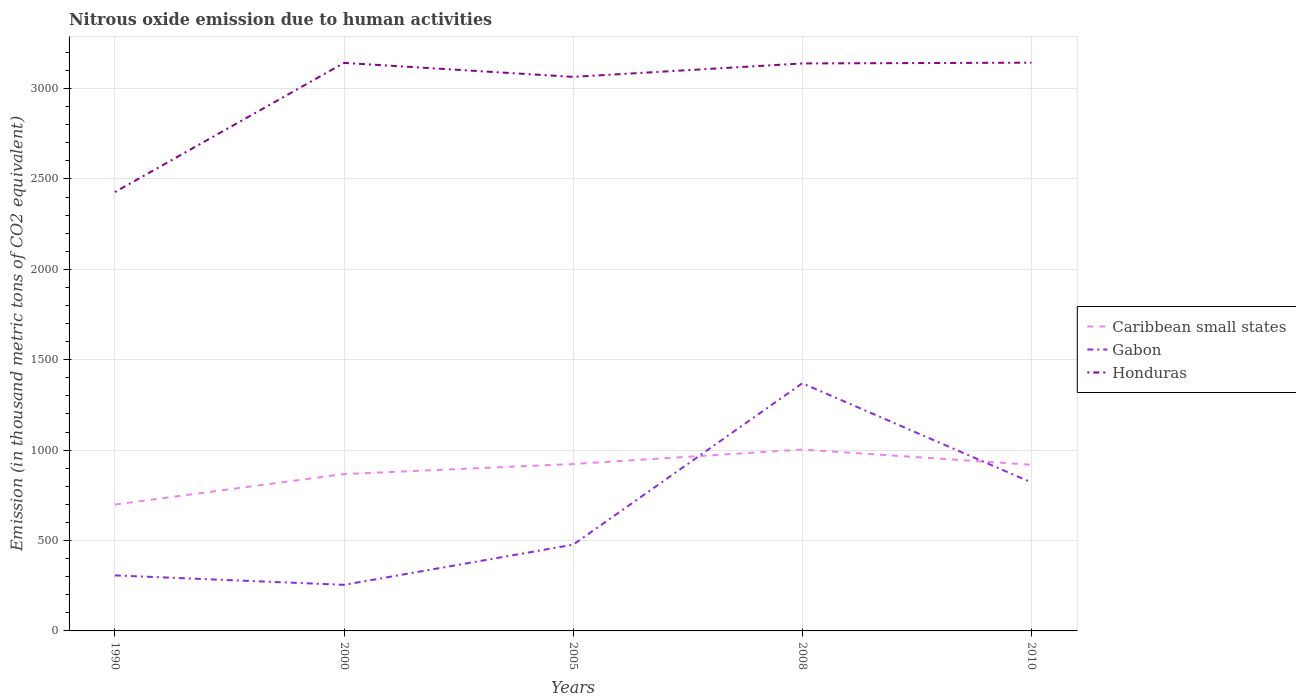Does the line corresponding to Honduras intersect with the line corresponding to Gabon?
Make the answer very short. No. Across all years, what is the maximum amount of nitrous oxide emitted in Caribbean small states?
Ensure brevity in your answer.  699.1. What is the total amount of nitrous oxide emitted in Caribbean small states in the graph?
Your response must be concise. -304.3. What is the difference between the highest and the second highest amount of nitrous oxide emitted in Gabon?
Give a very brief answer. 1115.1. How many lines are there?
Offer a terse response. 3. What is the difference between two consecutive major ticks on the Y-axis?
Your answer should be compact. 500. Does the graph contain any zero values?
Give a very brief answer. No. Does the graph contain grids?
Your response must be concise. Yes. Where does the legend appear in the graph?
Give a very brief answer. Center right. What is the title of the graph?
Your answer should be very brief. Nitrous oxide emission due to human activities. What is the label or title of the X-axis?
Offer a terse response. Years. What is the label or title of the Y-axis?
Provide a succinct answer. Emission (in thousand metric tons of CO2 equivalent). What is the Emission (in thousand metric tons of CO2 equivalent) in Caribbean small states in 1990?
Make the answer very short. 699.1. What is the Emission (in thousand metric tons of CO2 equivalent) of Gabon in 1990?
Offer a terse response. 307.1. What is the Emission (in thousand metric tons of CO2 equivalent) in Honduras in 1990?
Give a very brief answer. 2427.6. What is the Emission (in thousand metric tons of CO2 equivalent) of Caribbean small states in 2000?
Keep it short and to the point. 867.7. What is the Emission (in thousand metric tons of CO2 equivalent) of Gabon in 2000?
Provide a succinct answer. 254.9. What is the Emission (in thousand metric tons of CO2 equivalent) in Honduras in 2000?
Your response must be concise. 3142.2. What is the Emission (in thousand metric tons of CO2 equivalent) in Caribbean small states in 2005?
Your answer should be very brief. 923.3. What is the Emission (in thousand metric tons of CO2 equivalent) in Gabon in 2005?
Your answer should be very brief. 477.1. What is the Emission (in thousand metric tons of CO2 equivalent) in Honduras in 2005?
Make the answer very short. 3064.9. What is the Emission (in thousand metric tons of CO2 equivalent) of Caribbean small states in 2008?
Give a very brief answer. 1003.4. What is the Emission (in thousand metric tons of CO2 equivalent) in Gabon in 2008?
Your answer should be compact. 1370. What is the Emission (in thousand metric tons of CO2 equivalent) of Honduras in 2008?
Make the answer very short. 3139.2. What is the Emission (in thousand metric tons of CO2 equivalent) in Caribbean small states in 2010?
Offer a very short reply. 919.1. What is the Emission (in thousand metric tons of CO2 equivalent) in Gabon in 2010?
Your answer should be very brief. 821.3. What is the Emission (in thousand metric tons of CO2 equivalent) of Honduras in 2010?
Your answer should be very brief. 3143.4. Across all years, what is the maximum Emission (in thousand metric tons of CO2 equivalent) of Caribbean small states?
Give a very brief answer. 1003.4. Across all years, what is the maximum Emission (in thousand metric tons of CO2 equivalent) of Gabon?
Your answer should be compact. 1370. Across all years, what is the maximum Emission (in thousand metric tons of CO2 equivalent) in Honduras?
Ensure brevity in your answer.  3143.4. Across all years, what is the minimum Emission (in thousand metric tons of CO2 equivalent) of Caribbean small states?
Your response must be concise. 699.1. Across all years, what is the minimum Emission (in thousand metric tons of CO2 equivalent) in Gabon?
Your answer should be very brief. 254.9. Across all years, what is the minimum Emission (in thousand metric tons of CO2 equivalent) of Honduras?
Provide a succinct answer. 2427.6. What is the total Emission (in thousand metric tons of CO2 equivalent) in Caribbean small states in the graph?
Your response must be concise. 4412.6. What is the total Emission (in thousand metric tons of CO2 equivalent) of Gabon in the graph?
Ensure brevity in your answer.  3230.4. What is the total Emission (in thousand metric tons of CO2 equivalent) of Honduras in the graph?
Your response must be concise. 1.49e+04. What is the difference between the Emission (in thousand metric tons of CO2 equivalent) in Caribbean small states in 1990 and that in 2000?
Make the answer very short. -168.6. What is the difference between the Emission (in thousand metric tons of CO2 equivalent) in Gabon in 1990 and that in 2000?
Your answer should be compact. 52.2. What is the difference between the Emission (in thousand metric tons of CO2 equivalent) in Honduras in 1990 and that in 2000?
Keep it short and to the point. -714.6. What is the difference between the Emission (in thousand metric tons of CO2 equivalent) in Caribbean small states in 1990 and that in 2005?
Your answer should be very brief. -224.2. What is the difference between the Emission (in thousand metric tons of CO2 equivalent) of Gabon in 1990 and that in 2005?
Give a very brief answer. -170. What is the difference between the Emission (in thousand metric tons of CO2 equivalent) of Honduras in 1990 and that in 2005?
Keep it short and to the point. -637.3. What is the difference between the Emission (in thousand metric tons of CO2 equivalent) in Caribbean small states in 1990 and that in 2008?
Your answer should be compact. -304.3. What is the difference between the Emission (in thousand metric tons of CO2 equivalent) in Gabon in 1990 and that in 2008?
Give a very brief answer. -1062.9. What is the difference between the Emission (in thousand metric tons of CO2 equivalent) in Honduras in 1990 and that in 2008?
Provide a short and direct response. -711.6. What is the difference between the Emission (in thousand metric tons of CO2 equivalent) of Caribbean small states in 1990 and that in 2010?
Your answer should be compact. -220. What is the difference between the Emission (in thousand metric tons of CO2 equivalent) of Gabon in 1990 and that in 2010?
Provide a short and direct response. -514.2. What is the difference between the Emission (in thousand metric tons of CO2 equivalent) in Honduras in 1990 and that in 2010?
Your answer should be compact. -715.8. What is the difference between the Emission (in thousand metric tons of CO2 equivalent) in Caribbean small states in 2000 and that in 2005?
Your answer should be compact. -55.6. What is the difference between the Emission (in thousand metric tons of CO2 equivalent) in Gabon in 2000 and that in 2005?
Ensure brevity in your answer.  -222.2. What is the difference between the Emission (in thousand metric tons of CO2 equivalent) of Honduras in 2000 and that in 2005?
Your answer should be very brief. 77.3. What is the difference between the Emission (in thousand metric tons of CO2 equivalent) in Caribbean small states in 2000 and that in 2008?
Your answer should be compact. -135.7. What is the difference between the Emission (in thousand metric tons of CO2 equivalent) of Gabon in 2000 and that in 2008?
Give a very brief answer. -1115.1. What is the difference between the Emission (in thousand metric tons of CO2 equivalent) of Caribbean small states in 2000 and that in 2010?
Keep it short and to the point. -51.4. What is the difference between the Emission (in thousand metric tons of CO2 equivalent) in Gabon in 2000 and that in 2010?
Provide a short and direct response. -566.4. What is the difference between the Emission (in thousand metric tons of CO2 equivalent) of Honduras in 2000 and that in 2010?
Keep it short and to the point. -1.2. What is the difference between the Emission (in thousand metric tons of CO2 equivalent) in Caribbean small states in 2005 and that in 2008?
Offer a very short reply. -80.1. What is the difference between the Emission (in thousand metric tons of CO2 equivalent) in Gabon in 2005 and that in 2008?
Make the answer very short. -892.9. What is the difference between the Emission (in thousand metric tons of CO2 equivalent) of Honduras in 2005 and that in 2008?
Provide a succinct answer. -74.3. What is the difference between the Emission (in thousand metric tons of CO2 equivalent) in Caribbean small states in 2005 and that in 2010?
Keep it short and to the point. 4.2. What is the difference between the Emission (in thousand metric tons of CO2 equivalent) of Gabon in 2005 and that in 2010?
Ensure brevity in your answer.  -344.2. What is the difference between the Emission (in thousand metric tons of CO2 equivalent) in Honduras in 2005 and that in 2010?
Provide a short and direct response. -78.5. What is the difference between the Emission (in thousand metric tons of CO2 equivalent) of Caribbean small states in 2008 and that in 2010?
Your answer should be very brief. 84.3. What is the difference between the Emission (in thousand metric tons of CO2 equivalent) of Gabon in 2008 and that in 2010?
Keep it short and to the point. 548.7. What is the difference between the Emission (in thousand metric tons of CO2 equivalent) in Caribbean small states in 1990 and the Emission (in thousand metric tons of CO2 equivalent) in Gabon in 2000?
Give a very brief answer. 444.2. What is the difference between the Emission (in thousand metric tons of CO2 equivalent) in Caribbean small states in 1990 and the Emission (in thousand metric tons of CO2 equivalent) in Honduras in 2000?
Make the answer very short. -2443.1. What is the difference between the Emission (in thousand metric tons of CO2 equivalent) of Gabon in 1990 and the Emission (in thousand metric tons of CO2 equivalent) of Honduras in 2000?
Your answer should be very brief. -2835.1. What is the difference between the Emission (in thousand metric tons of CO2 equivalent) of Caribbean small states in 1990 and the Emission (in thousand metric tons of CO2 equivalent) of Gabon in 2005?
Make the answer very short. 222. What is the difference between the Emission (in thousand metric tons of CO2 equivalent) in Caribbean small states in 1990 and the Emission (in thousand metric tons of CO2 equivalent) in Honduras in 2005?
Ensure brevity in your answer.  -2365.8. What is the difference between the Emission (in thousand metric tons of CO2 equivalent) in Gabon in 1990 and the Emission (in thousand metric tons of CO2 equivalent) in Honduras in 2005?
Your answer should be compact. -2757.8. What is the difference between the Emission (in thousand metric tons of CO2 equivalent) in Caribbean small states in 1990 and the Emission (in thousand metric tons of CO2 equivalent) in Gabon in 2008?
Provide a succinct answer. -670.9. What is the difference between the Emission (in thousand metric tons of CO2 equivalent) of Caribbean small states in 1990 and the Emission (in thousand metric tons of CO2 equivalent) of Honduras in 2008?
Offer a terse response. -2440.1. What is the difference between the Emission (in thousand metric tons of CO2 equivalent) of Gabon in 1990 and the Emission (in thousand metric tons of CO2 equivalent) of Honduras in 2008?
Your answer should be very brief. -2832.1. What is the difference between the Emission (in thousand metric tons of CO2 equivalent) in Caribbean small states in 1990 and the Emission (in thousand metric tons of CO2 equivalent) in Gabon in 2010?
Make the answer very short. -122.2. What is the difference between the Emission (in thousand metric tons of CO2 equivalent) of Caribbean small states in 1990 and the Emission (in thousand metric tons of CO2 equivalent) of Honduras in 2010?
Make the answer very short. -2444.3. What is the difference between the Emission (in thousand metric tons of CO2 equivalent) in Gabon in 1990 and the Emission (in thousand metric tons of CO2 equivalent) in Honduras in 2010?
Your response must be concise. -2836.3. What is the difference between the Emission (in thousand metric tons of CO2 equivalent) of Caribbean small states in 2000 and the Emission (in thousand metric tons of CO2 equivalent) of Gabon in 2005?
Your response must be concise. 390.6. What is the difference between the Emission (in thousand metric tons of CO2 equivalent) of Caribbean small states in 2000 and the Emission (in thousand metric tons of CO2 equivalent) of Honduras in 2005?
Make the answer very short. -2197.2. What is the difference between the Emission (in thousand metric tons of CO2 equivalent) of Gabon in 2000 and the Emission (in thousand metric tons of CO2 equivalent) of Honduras in 2005?
Keep it short and to the point. -2810. What is the difference between the Emission (in thousand metric tons of CO2 equivalent) in Caribbean small states in 2000 and the Emission (in thousand metric tons of CO2 equivalent) in Gabon in 2008?
Your answer should be compact. -502.3. What is the difference between the Emission (in thousand metric tons of CO2 equivalent) in Caribbean small states in 2000 and the Emission (in thousand metric tons of CO2 equivalent) in Honduras in 2008?
Make the answer very short. -2271.5. What is the difference between the Emission (in thousand metric tons of CO2 equivalent) in Gabon in 2000 and the Emission (in thousand metric tons of CO2 equivalent) in Honduras in 2008?
Your answer should be very brief. -2884.3. What is the difference between the Emission (in thousand metric tons of CO2 equivalent) in Caribbean small states in 2000 and the Emission (in thousand metric tons of CO2 equivalent) in Gabon in 2010?
Your response must be concise. 46.4. What is the difference between the Emission (in thousand metric tons of CO2 equivalent) in Caribbean small states in 2000 and the Emission (in thousand metric tons of CO2 equivalent) in Honduras in 2010?
Provide a short and direct response. -2275.7. What is the difference between the Emission (in thousand metric tons of CO2 equivalent) of Gabon in 2000 and the Emission (in thousand metric tons of CO2 equivalent) of Honduras in 2010?
Give a very brief answer. -2888.5. What is the difference between the Emission (in thousand metric tons of CO2 equivalent) of Caribbean small states in 2005 and the Emission (in thousand metric tons of CO2 equivalent) of Gabon in 2008?
Offer a terse response. -446.7. What is the difference between the Emission (in thousand metric tons of CO2 equivalent) of Caribbean small states in 2005 and the Emission (in thousand metric tons of CO2 equivalent) of Honduras in 2008?
Give a very brief answer. -2215.9. What is the difference between the Emission (in thousand metric tons of CO2 equivalent) in Gabon in 2005 and the Emission (in thousand metric tons of CO2 equivalent) in Honduras in 2008?
Ensure brevity in your answer.  -2662.1. What is the difference between the Emission (in thousand metric tons of CO2 equivalent) of Caribbean small states in 2005 and the Emission (in thousand metric tons of CO2 equivalent) of Gabon in 2010?
Ensure brevity in your answer.  102. What is the difference between the Emission (in thousand metric tons of CO2 equivalent) in Caribbean small states in 2005 and the Emission (in thousand metric tons of CO2 equivalent) in Honduras in 2010?
Your answer should be compact. -2220.1. What is the difference between the Emission (in thousand metric tons of CO2 equivalent) of Gabon in 2005 and the Emission (in thousand metric tons of CO2 equivalent) of Honduras in 2010?
Your answer should be very brief. -2666.3. What is the difference between the Emission (in thousand metric tons of CO2 equivalent) of Caribbean small states in 2008 and the Emission (in thousand metric tons of CO2 equivalent) of Gabon in 2010?
Offer a terse response. 182.1. What is the difference between the Emission (in thousand metric tons of CO2 equivalent) of Caribbean small states in 2008 and the Emission (in thousand metric tons of CO2 equivalent) of Honduras in 2010?
Offer a very short reply. -2140. What is the difference between the Emission (in thousand metric tons of CO2 equivalent) in Gabon in 2008 and the Emission (in thousand metric tons of CO2 equivalent) in Honduras in 2010?
Give a very brief answer. -1773.4. What is the average Emission (in thousand metric tons of CO2 equivalent) of Caribbean small states per year?
Give a very brief answer. 882.52. What is the average Emission (in thousand metric tons of CO2 equivalent) in Gabon per year?
Your answer should be compact. 646.08. What is the average Emission (in thousand metric tons of CO2 equivalent) in Honduras per year?
Make the answer very short. 2983.46. In the year 1990, what is the difference between the Emission (in thousand metric tons of CO2 equivalent) in Caribbean small states and Emission (in thousand metric tons of CO2 equivalent) in Gabon?
Keep it short and to the point. 392. In the year 1990, what is the difference between the Emission (in thousand metric tons of CO2 equivalent) in Caribbean small states and Emission (in thousand metric tons of CO2 equivalent) in Honduras?
Your answer should be compact. -1728.5. In the year 1990, what is the difference between the Emission (in thousand metric tons of CO2 equivalent) of Gabon and Emission (in thousand metric tons of CO2 equivalent) of Honduras?
Ensure brevity in your answer.  -2120.5. In the year 2000, what is the difference between the Emission (in thousand metric tons of CO2 equivalent) of Caribbean small states and Emission (in thousand metric tons of CO2 equivalent) of Gabon?
Offer a very short reply. 612.8. In the year 2000, what is the difference between the Emission (in thousand metric tons of CO2 equivalent) of Caribbean small states and Emission (in thousand metric tons of CO2 equivalent) of Honduras?
Provide a succinct answer. -2274.5. In the year 2000, what is the difference between the Emission (in thousand metric tons of CO2 equivalent) in Gabon and Emission (in thousand metric tons of CO2 equivalent) in Honduras?
Your answer should be very brief. -2887.3. In the year 2005, what is the difference between the Emission (in thousand metric tons of CO2 equivalent) of Caribbean small states and Emission (in thousand metric tons of CO2 equivalent) of Gabon?
Keep it short and to the point. 446.2. In the year 2005, what is the difference between the Emission (in thousand metric tons of CO2 equivalent) in Caribbean small states and Emission (in thousand metric tons of CO2 equivalent) in Honduras?
Offer a terse response. -2141.6. In the year 2005, what is the difference between the Emission (in thousand metric tons of CO2 equivalent) in Gabon and Emission (in thousand metric tons of CO2 equivalent) in Honduras?
Your answer should be very brief. -2587.8. In the year 2008, what is the difference between the Emission (in thousand metric tons of CO2 equivalent) in Caribbean small states and Emission (in thousand metric tons of CO2 equivalent) in Gabon?
Make the answer very short. -366.6. In the year 2008, what is the difference between the Emission (in thousand metric tons of CO2 equivalent) of Caribbean small states and Emission (in thousand metric tons of CO2 equivalent) of Honduras?
Keep it short and to the point. -2135.8. In the year 2008, what is the difference between the Emission (in thousand metric tons of CO2 equivalent) in Gabon and Emission (in thousand metric tons of CO2 equivalent) in Honduras?
Your response must be concise. -1769.2. In the year 2010, what is the difference between the Emission (in thousand metric tons of CO2 equivalent) in Caribbean small states and Emission (in thousand metric tons of CO2 equivalent) in Gabon?
Offer a terse response. 97.8. In the year 2010, what is the difference between the Emission (in thousand metric tons of CO2 equivalent) of Caribbean small states and Emission (in thousand metric tons of CO2 equivalent) of Honduras?
Your answer should be compact. -2224.3. In the year 2010, what is the difference between the Emission (in thousand metric tons of CO2 equivalent) in Gabon and Emission (in thousand metric tons of CO2 equivalent) in Honduras?
Your response must be concise. -2322.1. What is the ratio of the Emission (in thousand metric tons of CO2 equivalent) in Caribbean small states in 1990 to that in 2000?
Ensure brevity in your answer.  0.81. What is the ratio of the Emission (in thousand metric tons of CO2 equivalent) of Gabon in 1990 to that in 2000?
Your answer should be very brief. 1.2. What is the ratio of the Emission (in thousand metric tons of CO2 equivalent) of Honduras in 1990 to that in 2000?
Make the answer very short. 0.77. What is the ratio of the Emission (in thousand metric tons of CO2 equivalent) of Caribbean small states in 1990 to that in 2005?
Your answer should be compact. 0.76. What is the ratio of the Emission (in thousand metric tons of CO2 equivalent) in Gabon in 1990 to that in 2005?
Your answer should be very brief. 0.64. What is the ratio of the Emission (in thousand metric tons of CO2 equivalent) of Honduras in 1990 to that in 2005?
Provide a succinct answer. 0.79. What is the ratio of the Emission (in thousand metric tons of CO2 equivalent) in Caribbean small states in 1990 to that in 2008?
Offer a terse response. 0.7. What is the ratio of the Emission (in thousand metric tons of CO2 equivalent) of Gabon in 1990 to that in 2008?
Keep it short and to the point. 0.22. What is the ratio of the Emission (in thousand metric tons of CO2 equivalent) of Honduras in 1990 to that in 2008?
Ensure brevity in your answer.  0.77. What is the ratio of the Emission (in thousand metric tons of CO2 equivalent) in Caribbean small states in 1990 to that in 2010?
Offer a terse response. 0.76. What is the ratio of the Emission (in thousand metric tons of CO2 equivalent) in Gabon in 1990 to that in 2010?
Ensure brevity in your answer.  0.37. What is the ratio of the Emission (in thousand metric tons of CO2 equivalent) in Honduras in 1990 to that in 2010?
Give a very brief answer. 0.77. What is the ratio of the Emission (in thousand metric tons of CO2 equivalent) in Caribbean small states in 2000 to that in 2005?
Provide a succinct answer. 0.94. What is the ratio of the Emission (in thousand metric tons of CO2 equivalent) of Gabon in 2000 to that in 2005?
Offer a terse response. 0.53. What is the ratio of the Emission (in thousand metric tons of CO2 equivalent) in Honduras in 2000 to that in 2005?
Keep it short and to the point. 1.03. What is the ratio of the Emission (in thousand metric tons of CO2 equivalent) in Caribbean small states in 2000 to that in 2008?
Your answer should be very brief. 0.86. What is the ratio of the Emission (in thousand metric tons of CO2 equivalent) in Gabon in 2000 to that in 2008?
Offer a very short reply. 0.19. What is the ratio of the Emission (in thousand metric tons of CO2 equivalent) of Caribbean small states in 2000 to that in 2010?
Your answer should be compact. 0.94. What is the ratio of the Emission (in thousand metric tons of CO2 equivalent) of Gabon in 2000 to that in 2010?
Ensure brevity in your answer.  0.31. What is the ratio of the Emission (in thousand metric tons of CO2 equivalent) of Caribbean small states in 2005 to that in 2008?
Your answer should be very brief. 0.92. What is the ratio of the Emission (in thousand metric tons of CO2 equivalent) of Gabon in 2005 to that in 2008?
Keep it short and to the point. 0.35. What is the ratio of the Emission (in thousand metric tons of CO2 equivalent) of Honduras in 2005 to that in 2008?
Provide a short and direct response. 0.98. What is the ratio of the Emission (in thousand metric tons of CO2 equivalent) of Caribbean small states in 2005 to that in 2010?
Offer a terse response. 1. What is the ratio of the Emission (in thousand metric tons of CO2 equivalent) in Gabon in 2005 to that in 2010?
Provide a short and direct response. 0.58. What is the ratio of the Emission (in thousand metric tons of CO2 equivalent) of Honduras in 2005 to that in 2010?
Provide a succinct answer. 0.97. What is the ratio of the Emission (in thousand metric tons of CO2 equivalent) of Caribbean small states in 2008 to that in 2010?
Offer a very short reply. 1.09. What is the ratio of the Emission (in thousand metric tons of CO2 equivalent) of Gabon in 2008 to that in 2010?
Offer a very short reply. 1.67. What is the ratio of the Emission (in thousand metric tons of CO2 equivalent) in Honduras in 2008 to that in 2010?
Your answer should be compact. 1. What is the difference between the highest and the second highest Emission (in thousand metric tons of CO2 equivalent) in Caribbean small states?
Offer a terse response. 80.1. What is the difference between the highest and the second highest Emission (in thousand metric tons of CO2 equivalent) of Gabon?
Make the answer very short. 548.7. What is the difference between the highest and the lowest Emission (in thousand metric tons of CO2 equivalent) of Caribbean small states?
Provide a succinct answer. 304.3. What is the difference between the highest and the lowest Emission (in thousand metric tons of CO2 equivalent) of Gabon?
Provide a short and direct response. 1115.1. What is the difference between the highest and the lowest Emission (in thousand metric tons of CO2 equivalent) of Honduras?
Make the answer very short. 715.8. 